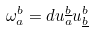<formula> <loc_0><loc_0><loc_500><loc_500>\omega ^ { b } _ { a } = d u _ { a } ^ { \underline { b } } u ^ { b } _ { \underline { b } }</formula> 